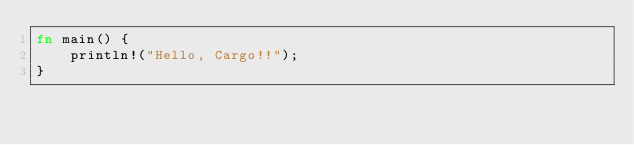Convert code to text. <code><loc_0><loc_0><loc_500><loc_500><_Rust_>fn main() {
    println!("Hello, Cargo!!");
}
</code> 